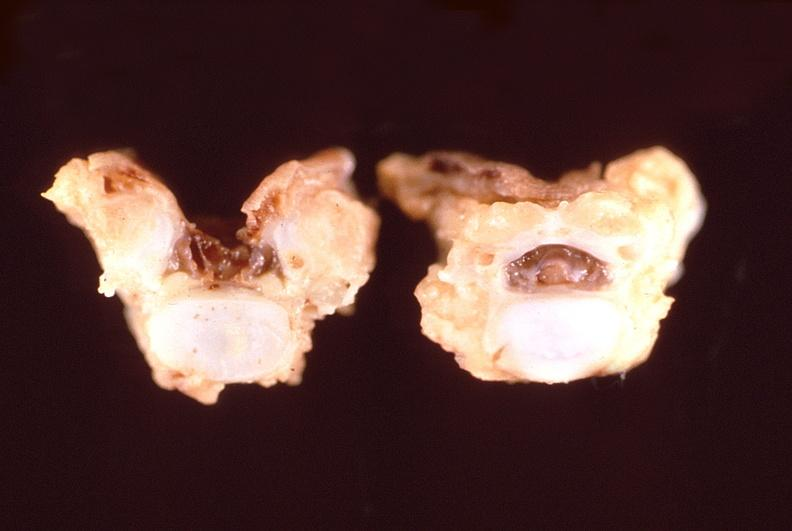what is present?
Answer the question using a single word or phrase. Nervous 